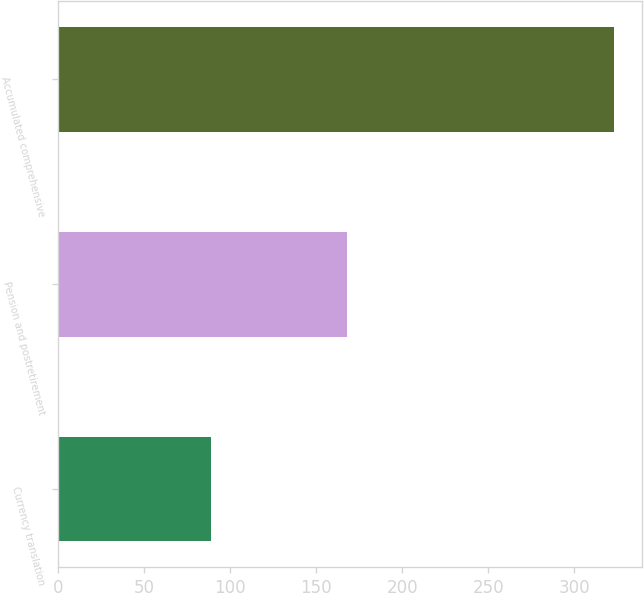Convert chart. <chart><loc_0><loc_0><loc_500><loc_500><bar_chart><fcel>Currency translation<fcel>Pension and postretirement<fcel>Accumulated comprehensive<nl><fcel>89<fcel>168<fcel>323<nl></chart> 